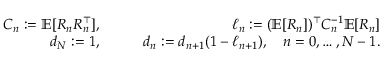<formula> <loc_0><loc_0><loc_500><loc_500>\begin{array} { r l r } { C _ { n } \colon = \mathbb { E } [ R _ { n } R _ { n } ^ { \top } ] , } & { \quad } & { \ell _ { n } \colon = ( \mathbb { E } [ R _ { n } ] ) ^ { \top } C _ { n } ^ { - 1 } \mathbb { E } [ R _ { n } ] } \\ { d _ { N } \colon = 1 , } & { \quad } & { d _ { n } \colon = d _ { n + 1 } ( 1 - \ell _ { n + 1 } ) , \quad n = 0 , \dots , N - 1 . } \end{array}</formula> 